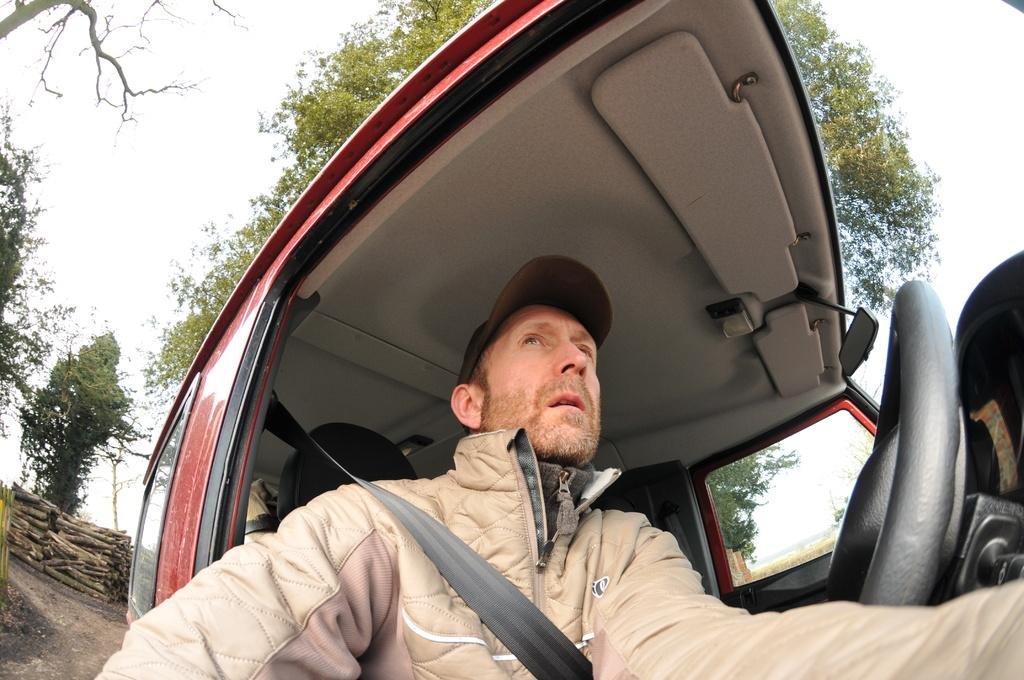What is the man in the image doing? The man is sitting in a car. What can be seen in the background of the image? Trees and the sky are visible in the image. What objects are present in the image besides the car? Bamboo sticks are present in the image. What type of crow is perched on the man's head in the image? There is no crow present in the image; the man is sitting in a car with no crow visible. 